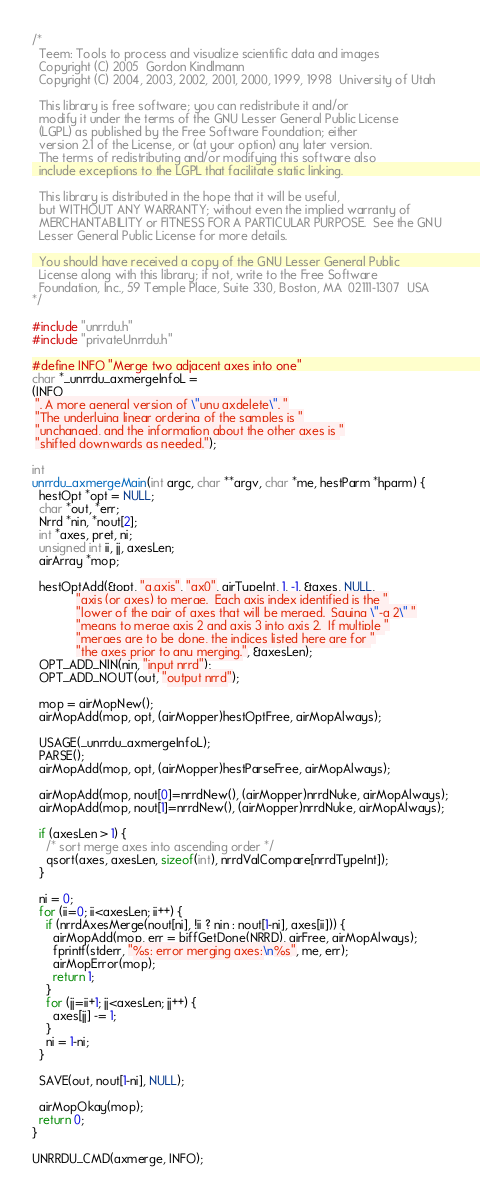<code> <loc_0><loc_0><loc_500><loc_500><_C_>/*
  Teem: Tools to process and visualize scientific data and images
  Copyright (C) 2005  Gordon Kindlmann
  Copyright (C) 2004, 2003, 2002, 2001, 2000, 1999, 1998  University of Utah

  This library is free software; you can redistribute it and/or
  modify it under the terms of the GNU Lesser General Public License
  (LGPL) as published by the Free Software Foundation; either
  version 2.1 of the License, or (at your option) any later version.
  The terms of redistributing and/or modifying this software also
  include exceptions to the LGPL that facilitate static linking.

  This library is distributed in the hope that it will be useful,
  but WITHOUT ANY WARRANTY; without even the implied warranty of
  MERCHANTABILITY or FITNESS FOR A PARTICULAR PURPOSE.  See the GNU
  Lesser General Public License for more details.

  You should have received a copy of the GNU Lesser General Public
  License along with this library; if not, write to the Free Software
  Foundation, Inc., 59 Temple Place, Suite 330, Boston, MA  02111-1307  USA
*/

#include "unrrdu.h"
#include "privateUnrrdu.h"

#define INFO "Merge two adjacent axes into one"
char *_unrrdu_axmergeInfoL =
(INFO
 ". A more general version of \"unu axdelete\". "
 "The underlying linear ordering of the samples is "
 "unchanged, and the information about the other axes is "
 "shifted downwards as needed.");

int
unrrdu_axmergeMain(int argc, char **argv, char *me, hestParm *hparm) {
  hestOpt *opt = NULL;
  char *out, *err;
  Nrrd *nin, *nout[2];
  int *axes, pret, ni;
  unsigned int ii, jj, axesLen;
  airArray *mop;

  hestOptAdd(&opt, "a,axis", "ax0", airTypeInt, 1, -1, &axes, NULL,
             "axis (or axes) to merge.  Each axis index identified is the "
             "lower of the pair of axes that will be merged.  Saying \"-a 2\" "
             "means to merge axis 2 and axis 3 into axis 2.  If multiple "
             "merges are to be done, the indices listed here are for "
             "the axes prior to any merging.", &axesLen);
  OPT_ADD_NIN(nin, "input nrrd");
  OPT_ADD_NOUT(out, "output nrrd");

  mop = airMopNew();
  airMopAdd(mop, opt, (airMopper)hestOptFree, airMopAlways);

  USAGE(_unrrdu_axmergeInfoL);
  PARSE();
  airMopAdd(mop, opt, (airMopper)hestParseFree, airMopAlways);

  airMopAdd(mop, nout[0]=nrrdNew(), (airMopper)nrrdNuke, airMopAlways);
  airMopAdd(mop, nout[1]=nrrdNew(), (airMopper)nrrdNuke, airMopAlways);

  if (axesLen > 1) {
    /* sort merge axes into ascending order */
    qsort(axes, axesLen, sizeof(int), nrrdValCompare[nrrdTypeInt]);
  }

  ni = 0;
  for (ii=0; ii<axesLen; ii++) {
    if (nrrdAxesMerge(nout[ni], !ii ? nin : nout[1-ni], axes[ii])) {
      airMopAdd(mop, err = biffGetDone(NRRD), airFree, airMopAlways);
      fprintf(stderr, "%s: error merging axes:\n%s", me, err);
      airMopError(mop);
      return 1;
    }
    for (jj=ii+1; jj<axesLen; jj++) {
      axes[jj] -= 1;
    }
    ni = 1-ni;
  }
  
  SAVE(out, nout[1-ni], NULL);

  airMopOkay(mop);
  return 0;
}

UNRRDU_CMD(axmerge, INFO);
</code> 